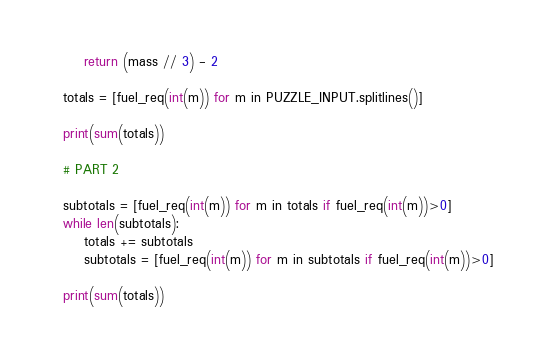Convert code to text. <code><loc_0><loc_0><loc_500><loc_500><_Python_>    return (mass // 3) - 2

totals = [fuel_req(int(m)) for m in PUZZLE_INPUT.splitlines()]

print(sum(totals))

# PART 2

subtotals = [fuel_req(int(m)) for m in totals if fuel_req(int(m))>0]
while len(subtotals):
    totals += subtotals
    subtotals = [fuel_req(int(m)) for m in subtotals if fuel_req(int(m))>0]

print(sum(totals))
</code> 